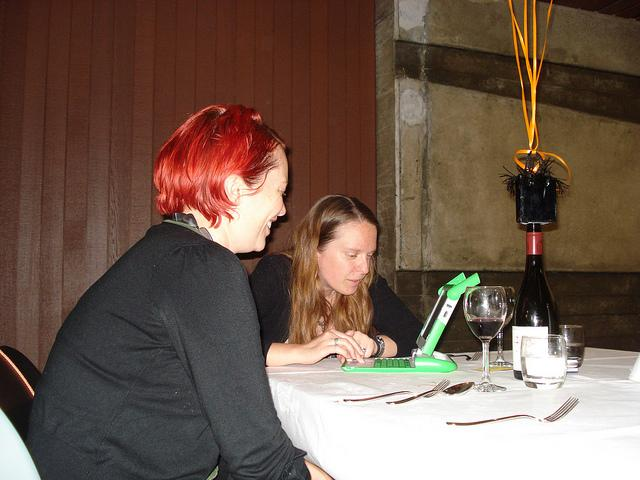Which process has been performed on the closer lady's hair? Please explain your reasoning. dying. The hair is a little bright to be a natural color. 